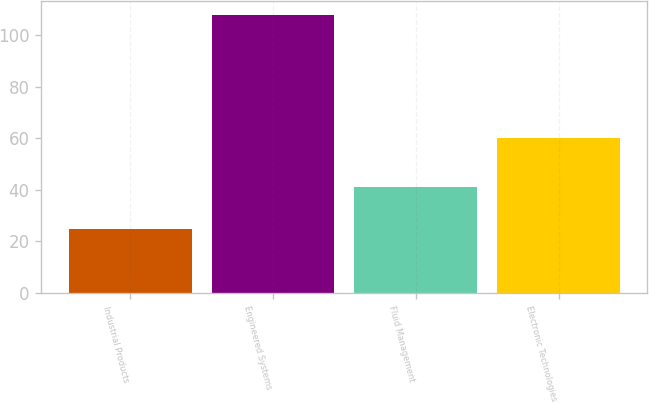<chart> <loc_0><loc_0><loc_500><loc_500><bar_chart><fcel>Industrial Products<fcel>Engineered Systems<fcel>Fluid Management<fcel>Electronic Technologies<nl><fcel>25<fcel>108<fcel>41<fcel>60<nl></chart> 